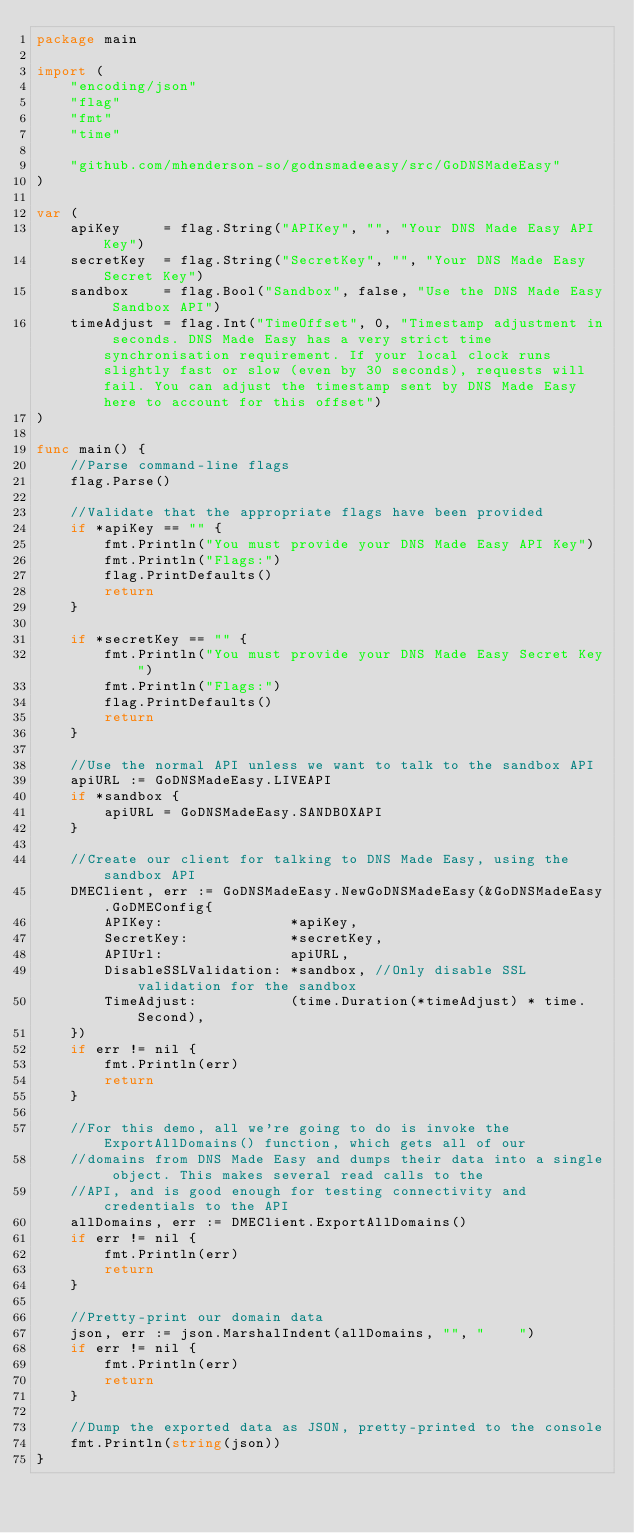Convert code to text. <code><loc_0><loc_0><loc_500><loc_500><_Go_>package main

import (
	"encoding/json"
	"flag"
	"fmt"
	"time"

	"github.com/mhenderson-so/godnsmadeeasy/src/GoDNSMadeEasy"
)

var (
	apiKey     = flag.String("APIKey", "", "Your DNS Made Easy API Key")
	secretKey  = flag.String("SecretKey", "", "Your DNS Made Easy Secret Key")
	sandbox    = flag.Bool("Sandbox", false, "Use the DNS Made Easy Sandbox API")
	timeAdjust = flag.Int("TimeOffset", 0, "Timestamp adjustment in seconds. DNS Made Easy has a very strict time synchronisation requirement. If your local clock runs slightly fast or slow (even by 30 seconds), requests will fail. You can adjust the timestamp sent by DNS Made Easy here to account for this offset")
)

func main() {
	//Parse command-line flags
	flag.Parse()

	//Validate that the appropriate flags have been provided
	if *apiKey == "" {
		fmt.Println("You must provide your DNS Made Easy API Key")
		fmt.Println("Flags:")
		flag.PrintDefaults()
		return
	}

	if *secretKey == "" {
		fmt.Println("You must provide your DNS Made Easy Secret Key")
		fmt.Println("Flags:")
		flag.PrintDefaults()
		return
	}

	//Use the normal API unless we want to talk to the sandbox API
	apiURL := GoDNSMadeEasy.LIVEAPI
	if *sandbox {
		apiURL = GoDNSMadeEasy.SANDBOXAPI
	}

	//Create our client for talking to DNS Made Easy, using the sandbox API
	DMEClient, err := GoDNSMadeEasy.NewGoDNSMadeEasy(&GoDNSMadeEasy.GoDMEConfig{
		APIKey:               *apiKey,
		SecretKey:            *secretKey,
		APIUrl:               apiURL,
		DisableSSLValidation: *sandbox, //Only disable SSL validation for the sandbox
		TimeAdjust:           (time.Duration(*timeAdjust) * time.Second),
	})
	if err != nil {
		fmt.Println(err)
		return
	}

	//For this demo, all we're going to do is invoke the ExportAllDomains() function, which gets all of our
	//domains from DNS Made Easy and dumps their data into a single object. This makes several read calls to the
	//API, and is good enough for testing connectivity and credentials to the API
	allDomains, err := DMEClient.ExportAllDomains()
	if err != nil {
		fmt.Println(err)
		return
	}

	//Pretty-print our domain data
	json, err := json.MarshalIndent(allDomains, "", "    ")
	if err != nil {
		fmt.Println(err)
		return
	}

	//Dump the exported data as JSON, pretty-printed to the console
	fmt.Println(string(json))
}
</code> 